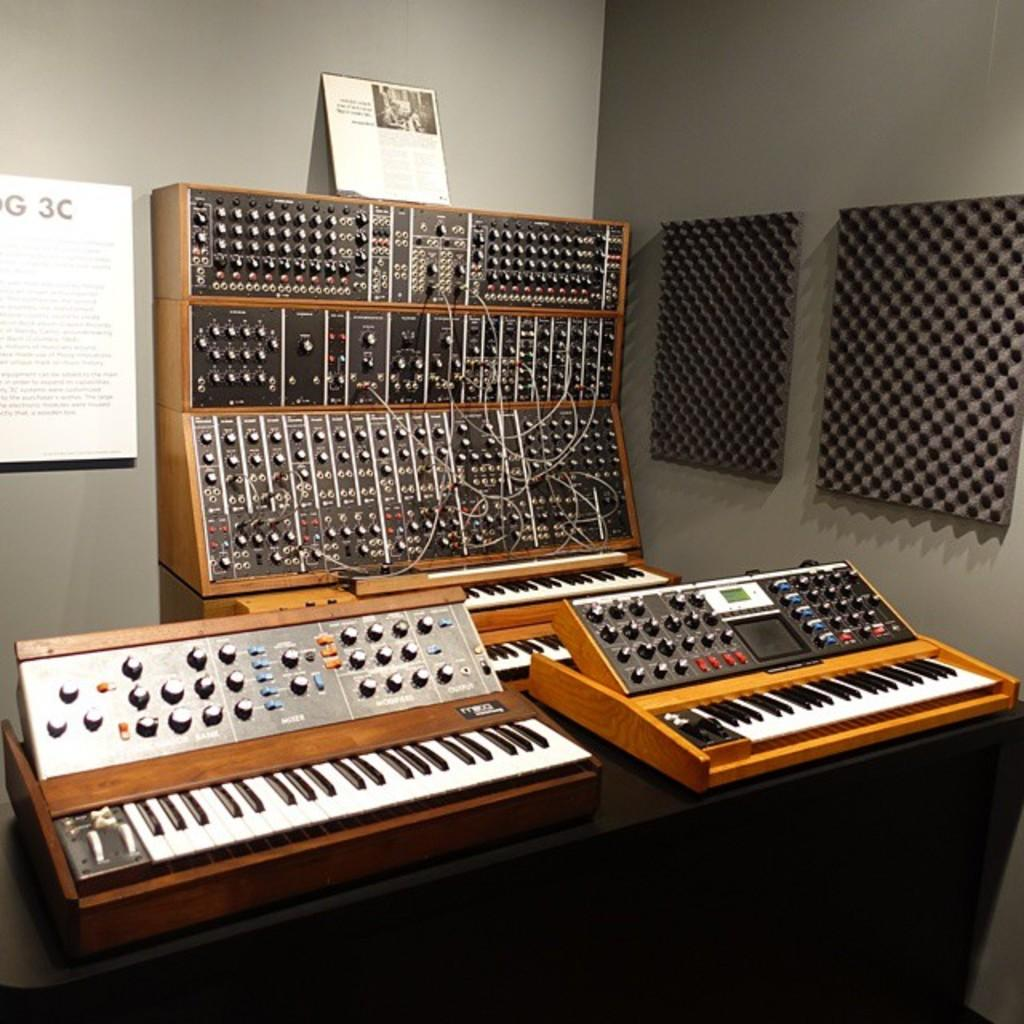What type of equipment is present in the image? There are keyboards in the image. What other items can be seen in the image? There are musical instruments in the image. What decorative elements are present on the walls in the image? There are wall posters in the room. What type of birds can be seen flying on the side of the wall in the image? There are no birds present in the image; it features keyboards, musical instruments, and wall posters. 